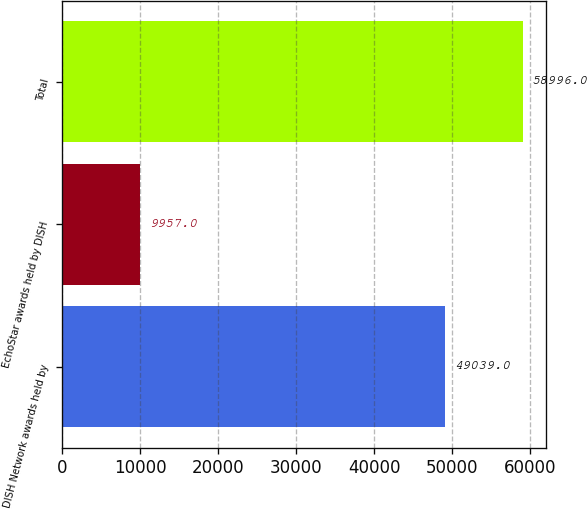Convert chart. <chart><loc_0><loc_0><loc_500><loc_500><bar_chart><fcel>DISH Network awards held by<fcel>EchoStar awards held by DISH<fcel>Total<nl><fcel>49039<fcel>9957<fcel>58996<nl></chart> 